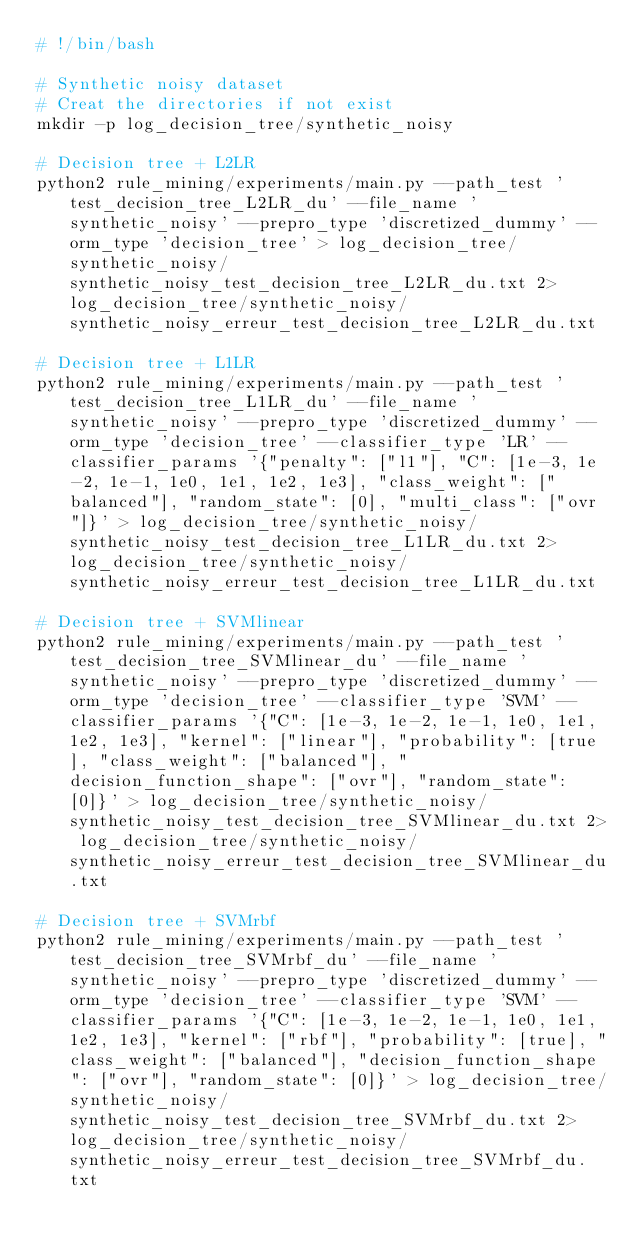Convert code to text. <code><loc_0><loc_0><loc_500><loc_500><_Bash_># !/bin/bash

# Synthetic noisy dataset
# Creat the directories if not exist
mkdir -p log_decision_tree/synthetic_noisy

# Decision tree + L2LR
python2 rule_mining/experiments/main.py --path_test 'test_decision_tree_L2LR_du' --file_name 'synthetic_noisy' --prepro_type 'discretized_dummy' --orm_type 'decision_tree' > log_decision_tree/synthetic_noisy/synthetic_noisy_test_decision_tree_L2LR_du.txt 2> log_decision_tree/synthetic_noisy/synthetic_noisy_erreur_test_decision_tree_L2LR_du.txt

# Decision tree + L1LR
python2 rule_mining/experiments/main.py --path_test 'test_decision_tree_L1LR_du' --file_name 'synthetic_noisy' --prepro_type 'discretized_dummy' --orm_type 'decision_tree' --classifier_type 'LR' --classifier_params '{"penalty": ["l1"], "C": [1e-3, 1e-2, 1e-1, 1e0, 1e1, 1e2, 1e3], "class_weight": ["balanced"], "random_state": [0], "multi_class": ["ovr"]}' > log_decision_tree/synthetic_noisy/synthetic_noisy_test_decision_tree_L1LR_du.txt 2> log_decision_tree/synthetic_noisy/synthetic_noisy_erreur_test_decision_tree_L1LR_du.txt

# Decision tree + SVMlinear
python2 rule_mining/experiments/main.py --path_test 'test_decision_tree_SVMlinear_du' --file_name 'synthetic_noisy' --prepro_type 'discretized_dummy' --orm_type 'decision_tree' --classifier_type 'SVM' --classifier_params '{"C": [1e-3, 1e-2, 1e-1, 1e0, 1e1, 1e2, 1e3], "kernel": ["linear"], "probability": [true], "class_weight": ["balanced"], "decision_function_shape": ["ovr"], "random_state": [0]}' > log_decision_tree/synthetic_noisy/synthetic_noisy_test_decision_tree_SVMlinear_du.txt 2> log_decision_tree/synthetic_noisy/synthetic_noisy_erreur_test_decision_tree_SVMlinear_du.txt

# Decision tree + SVMrbf
python2 rule_mining/experiments/main.py --path_test 'test_decision_tree_SVMrbf_du' --file_name 'synthetic_noisy' --prepro_type 'discretized_dummy' --orm_type 'decision_tree' --classifier_type 'SVM' --classifier_params '{"C": [1e-3, 1e-2, 1e-1, 1e0, 1e1, 1e2, 1e3], "kernel": ["rbf"], "probability": [true], "class_weight": ["balanced"], "decision_function_shape": ["ovr"], "random_state": [0]}' > log_decision_tree/synthetic_noisy/synthetic_noisy_test_decision_tree_SVMrbf_du.txt 2> log_decision_tree/synthetic_noisy/synthetic_noisy_erreur_test_decision_tree_SVMrbf_du.txt
</code> 